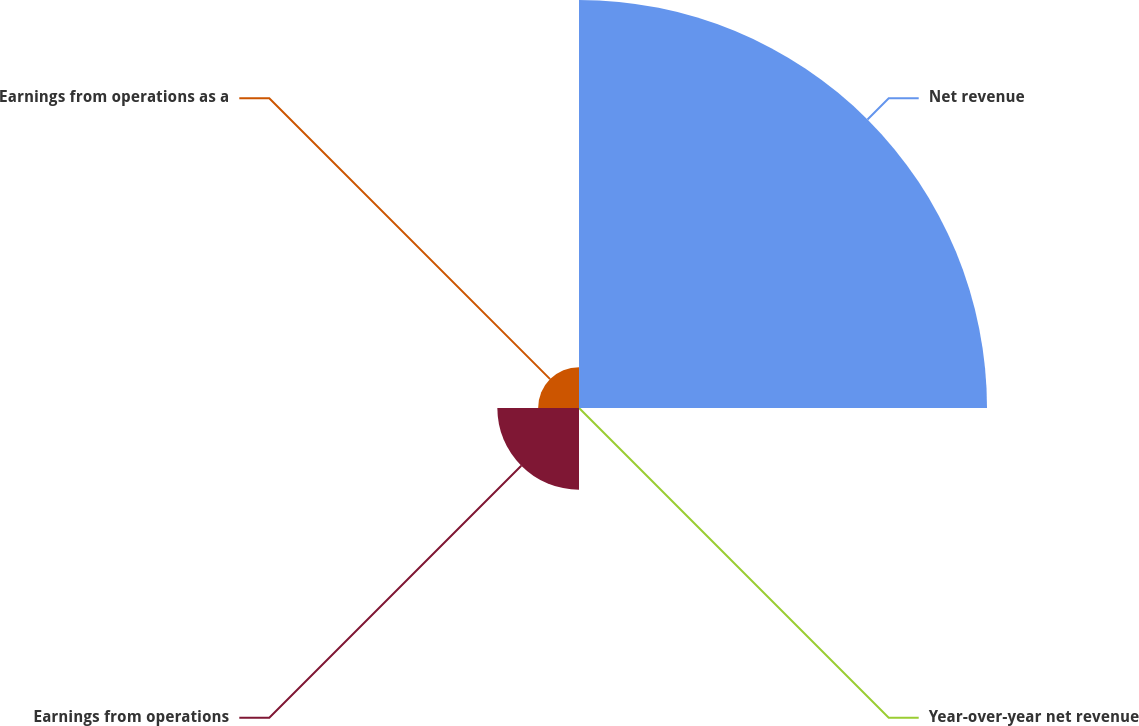<chart> <loc_0><loc_0><loc_500><loc_500><pie_chart><fcel>Net revenue<fcel>Year-over-year net revenue<fcel>Earnings from operations<fcel>Earnings from operations as a<nl><fcel>76.89%<fcel>0.02%<fcel>15.39%<fcel>7.7%<nl></chart> 